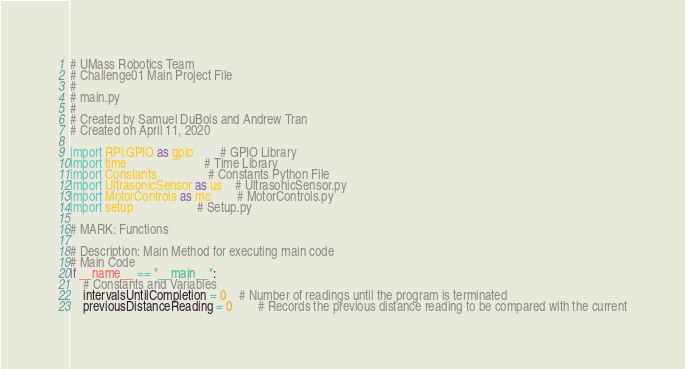Convert code to text. <code><loc_0><loc_0><loc_500><loc_500><_Python_># UMass Robotics Team
# Challenge01 Main Project File
#
# main.py
#
# Created by Samuel DuBois and Andrew Tran
# Created on April 11, 2020

import RPi.GPIO as gpio 		# GPIO Library
import time						# Time Library
import Constants 				# Constants Python File
import UltrasonicSensor as us	# UltrasonicSensor.py
import MotorControls as mc		# MotorControls.py
import setup 					# Setup.py

# MARK: Functions

# Description: Main Method for executing main code
# Main Code
if __name__ == "__main__":
	# Constants and Variables
	intervalsUntilCompletion = 0	# Number of readings until the program is terminated
	previousDistanceReading = 0		# Records the previous distance reading to be compared with the current</code> 